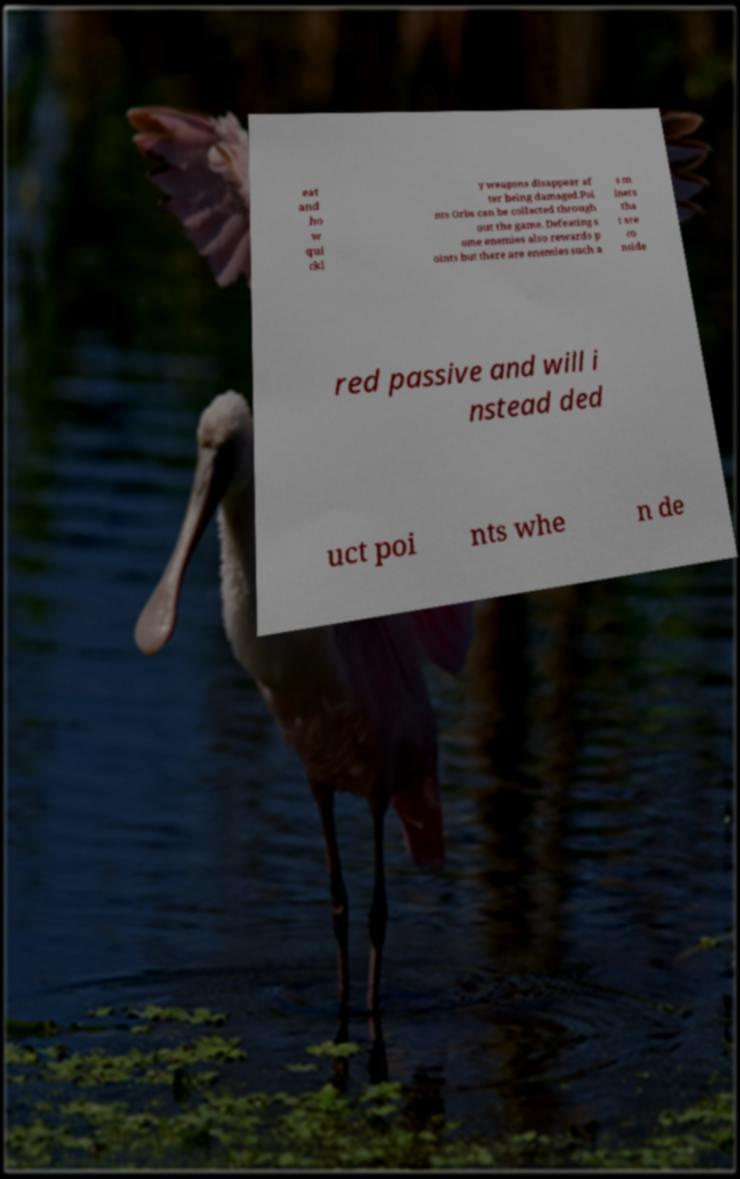Please identify and transcribe the text found in this image. eat and ho w qui ckl y weapons disappear af ter being damaged.Poi nts Orbs can be collected through out the game. Defeating s ome enemies also rewards p oints but there are enemies such a s m iners tha t are co nside red passive and will i nstead ded uct poi nts whe n de 